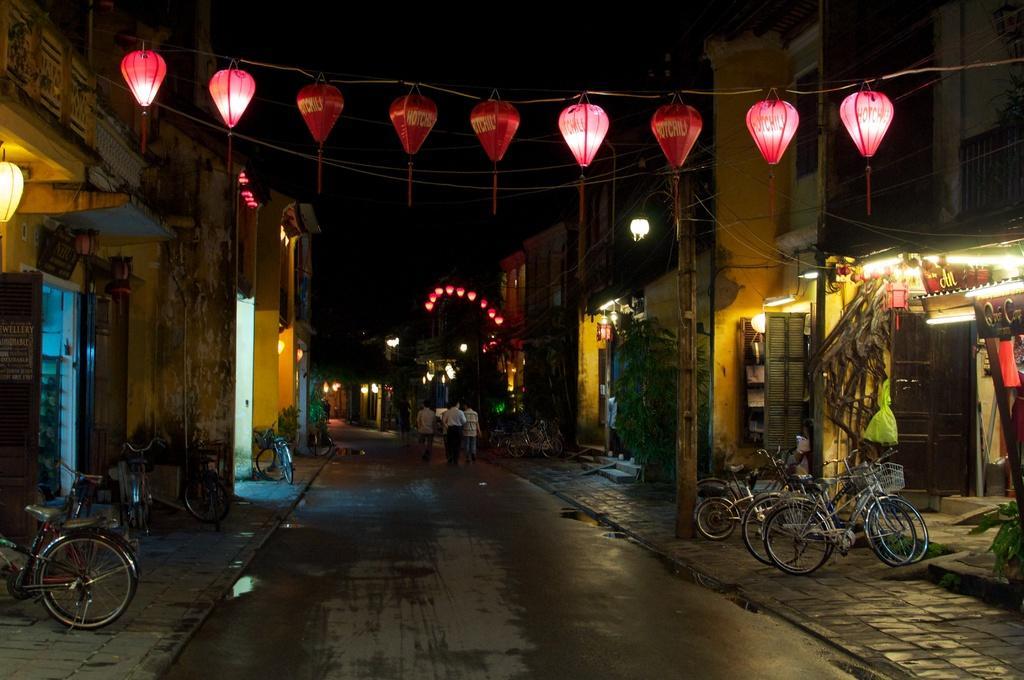In one or two sentences, can you explain what this image depicts? In this image we can see bicycles parked on the sidewalk, people walking on the road, lamps hanged here, the buildings on the either side, and the background is dark in color. 